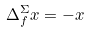<formula> <loc_0><loc_0><loc_500><loc_500>\Delta _ { f } ^ { \Sigma } x = - x</formula> 